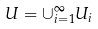<formula> <loc_0><loc_0><loc_500><loc_500>U = \cup _ { i = 1 } ^ { \infty } U _ { i }</formula> 